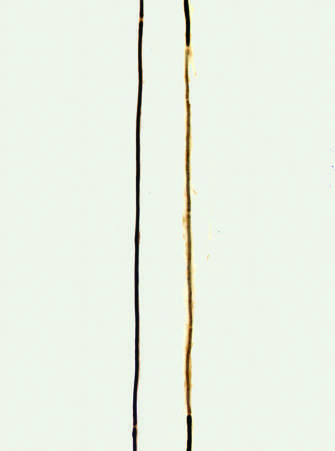does this full-thickness histologic section show a segment surrounded by a series of thinly myelinated internodes of uneven length flanked on both ends by normal thicker myelin internodes?
Answer the question using a single word or phrase. No 